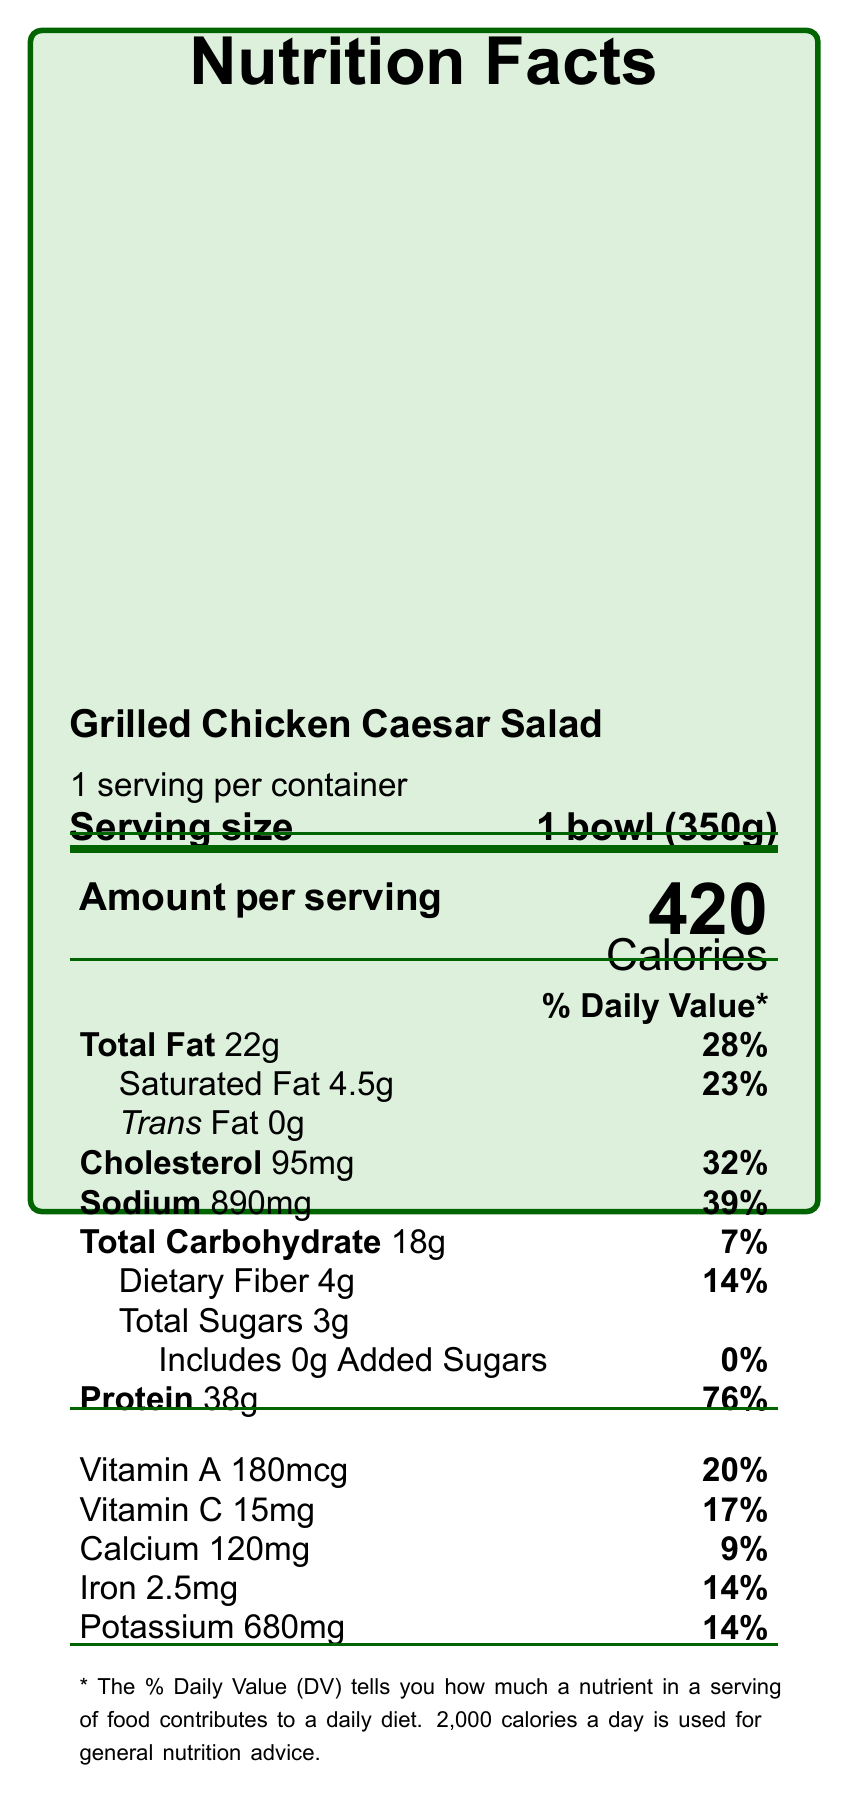what is the serving size? The serving size is stated as "1 bowl (350g)" in the document.
Answer: 1 bowl (350g) how many calories are in one serving? The document specifies that there are 420 calories per serving.
Answer: 420 what is the total fat content in one serving? The total fat content per serving is listed as 22g.
Answer: 22g What percentage of the daily recommended value is the total fat in one serving? The document shows that the total fat content is 28% of the daily recommended value.
Answer: 28% how much protein does one serving provide? The amount of protein per serving is given as 38g.
Answer: 38g how much dietary fiber is in one serving? The dietary fiber content per serving is listed as 4g.
Answer: 4g how much sodium is in a serving of Grilled Chicken Caesar Salad? The sodium content per serving is indicated to be 890mg.
Answer: 890mg what are the allergens listed for this product? The allergens specified in the document include Egg, Milk, Wheat, and Fish (anchovy).
Answer: Egg, Milk, Wheat, Fish (anchovy) how is the chicken sourced for this product? The document mentions that the chicken is sourced from local, free-range farms.
Answer: Local, free-range farms What percentage of the daily recommended value does the protein in this product provide? A. 32% B. 39% C. 76% D. 14% The protein content provides 76% of the daily recommended value.
Answer: C. 76% Which nutrient provides the highest percentage of the daily recommended value in this product? According to the percentages listed, protein provides the highest daily value at 76%.
Answer: Protein what is the main idea of this document? The document is a nutritional label for a specific meal, detailing various nutritional components, potential allergens, and additional information about the ingredients and their sourcing.
Answer: The document provides detailed nutrition facts and information for a Grilled Chicken Caesar Salad, including serving size, calories, macronutrient and micronutrient content, allergens, and sustainability information. Does the product contain any trans fat? The document specifically indicates that the product contains 0g of trans fat.
Answer: No Is the vitamin C content in one serving of this product high? The vitamin C content is 15mg, which is 17% of the daily recommended value, indicating that it is a good source.
Answer: Yes What are the ingredients in the Caesar dressing? The document includes a detailed list of ingredients used in the Caesar dressing.
Answer: Olive oil, anchovy paste, egg yolk, lemon juice, Parmesan cheese, garlic, Dijon mustard, black pepper how many grams of added sugars does the salad contain? The document specifies that the salad contains 0g of added sugars.
Answer: 0g how many servings are there per container? The serving per container is listed as 1.
Answer: 1 Please describe the preparation method for this product. The document mentions that the preparation method involves grilled chicken and a tossed salad.
Answer: Grilled chicken, tossed salad what are the main vitamin contributions of this product? The document lists vitamin A and vitamin C as significant contributors, providing 20% and 17% of the daily recommended values, respectively.
Answer: Vitamin A (20%) and Vitamin C (17%) what does the meal plan category of 'Balanced Option' mean in the context of this product? The document does not provide a definition for the meal plan category of 'Balanced Option'.
Answer: Not enough information 